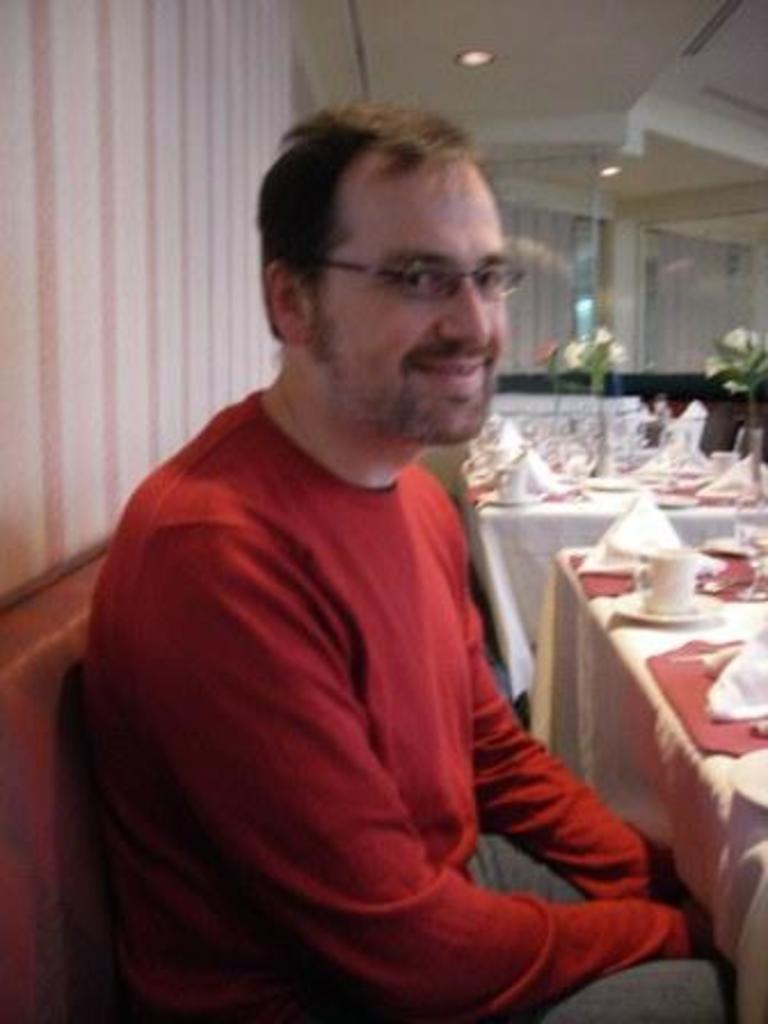Could you give a brief overview of what you see in this image? In the center of the image we can see one person is sitting and he is smiling. And we can see he is wearing glasses and he is in a red t shirt. In front of him, we can see one table. On the table, we can see one cloth, saucer, cup and a few other objects. In the background there is a wall, lights, curtains, one table and a few other objects. 